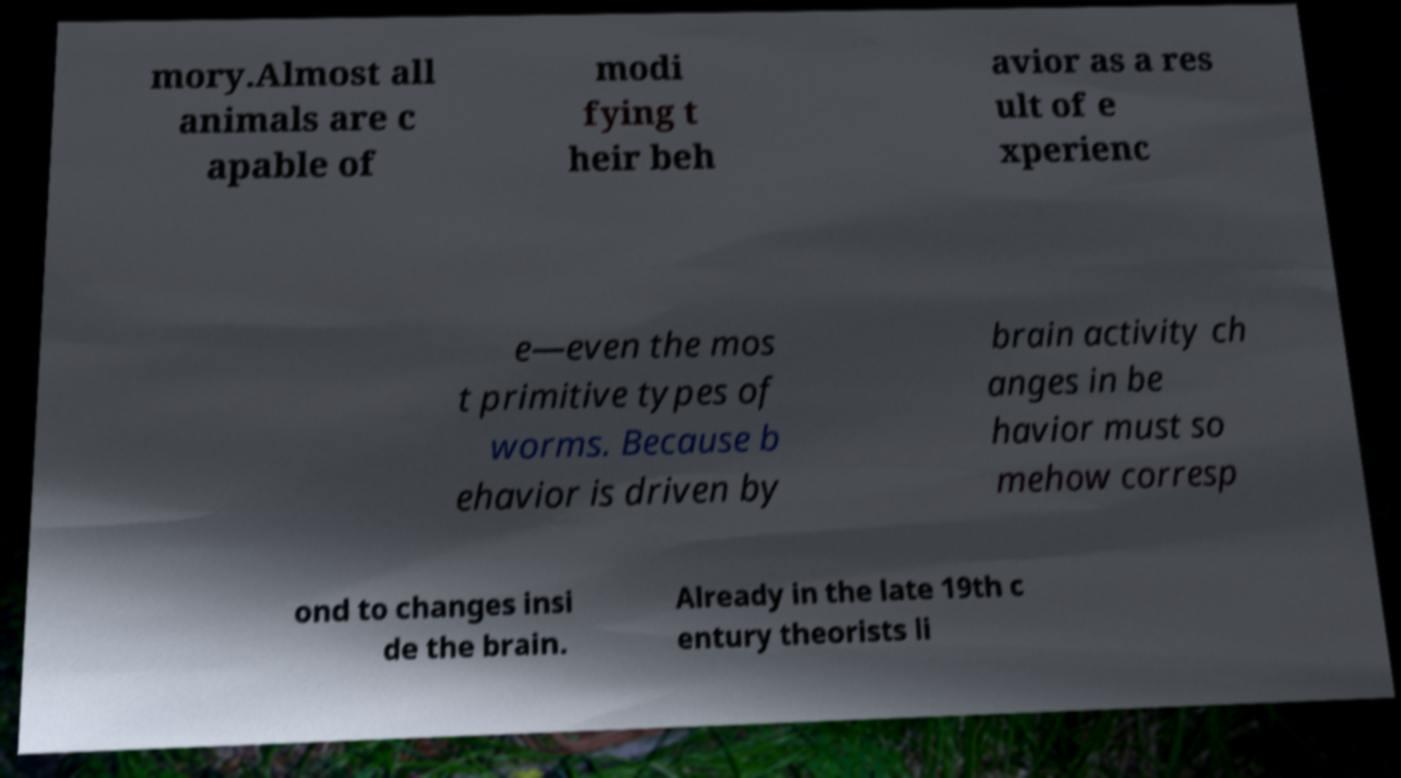Please identify and transcribe the text found in this image. mory.Almost all animals are c apable of modi fying t heir beh avior as a res ult of e xperienc e—even the mos t primitive types of worms. Because b ehavior is driven by brain activity ch anges in be havior must so mehow corresp ond to changes insi de the brain. Already in the late 19th c entury theorists li 